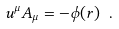<formula> <loc_0><loc_0><loc_500><loc_500>u ^ { \mu } A _ { \mu } = - \phi ( r ) \ .</formula> 